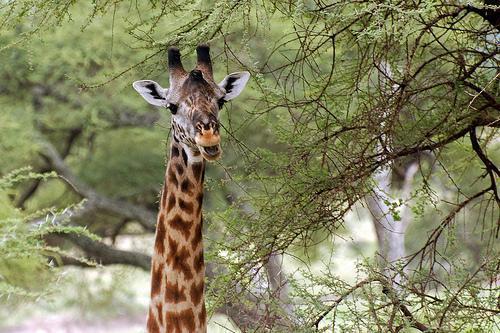How many giraffes are there?
Give a very brief answer. 1. How many zebras are eating the tree?
Give a very brief answer. 0. 